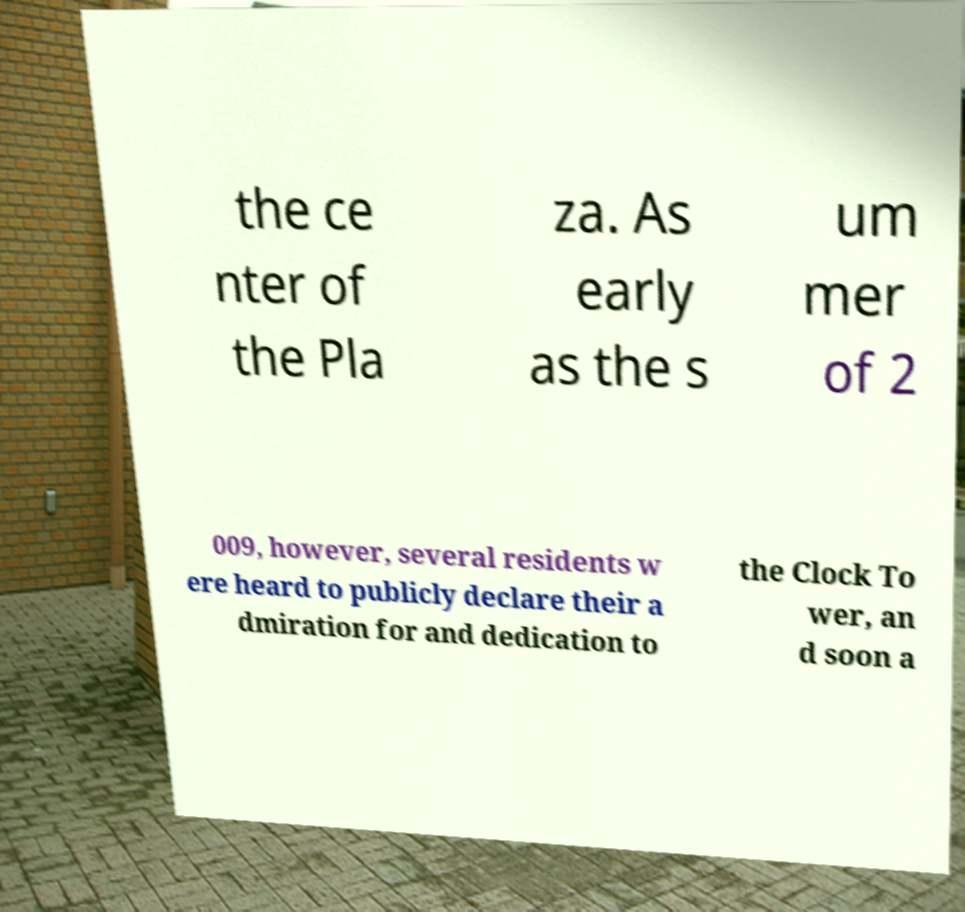Can you accurately transcribe the text from the provided image for me? the ce nter of the Pla za. As early as the s um mer of 2 009, however, several residents w ere heard to publicly declare their a dmiration for and dedication to the Clock To wer, an d soon a 